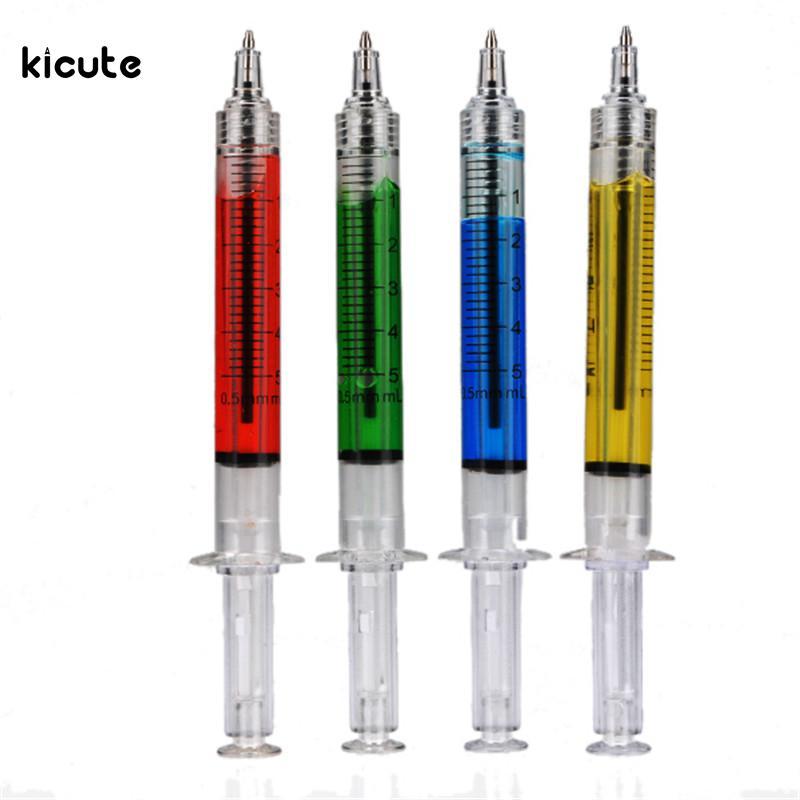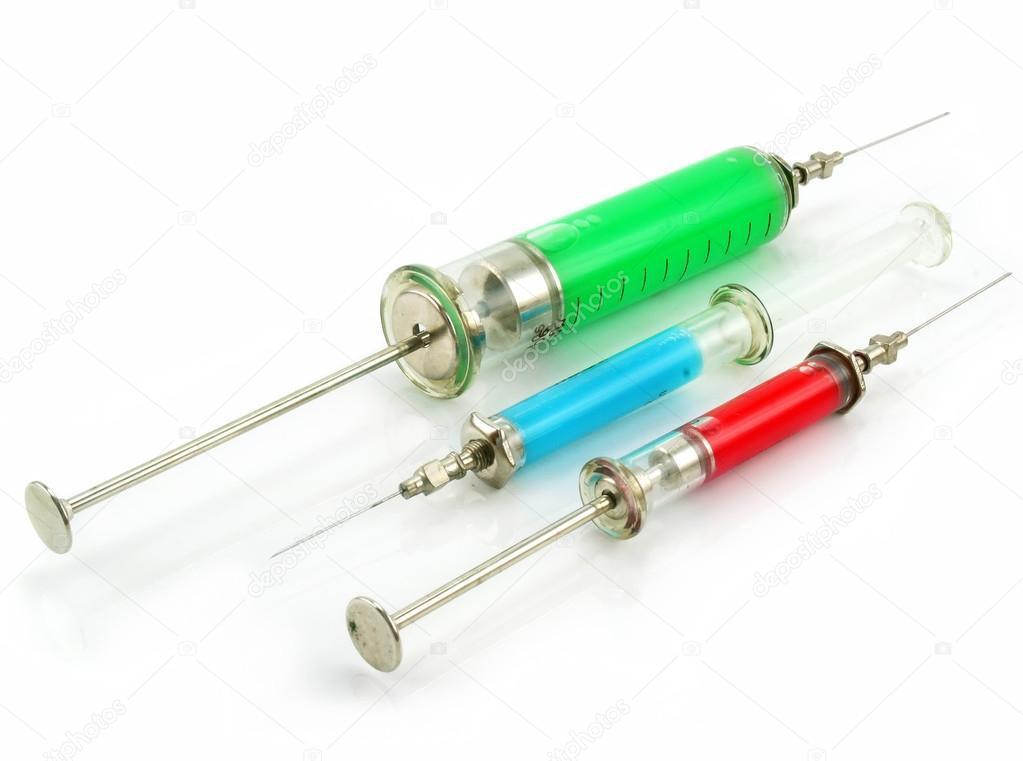The first image is the image on the left, the second image is the image on the right. Assess this claim about the two images: "The syringe in the right image furthest to the right has a red substance inside it.". Correct or not? Answer yes or no. Yes. The first image is the image on the left, the second image is the image on the right. Evaluate the accuracy of this statement regarding the images: "An image includes exactly three syringes displayed side-by-side at the same diagonal angle.". Is it true? Answer yes or no. Yes. 